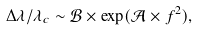<formula> <loc_0><loc_0><loc_500><loc_500>\Delta \lambda / \lambda _ { c } \sim { \mathcal { B } } \times \exp ( { \mathcal { A } } \times f ^ { 2 } ) ,</formula> 